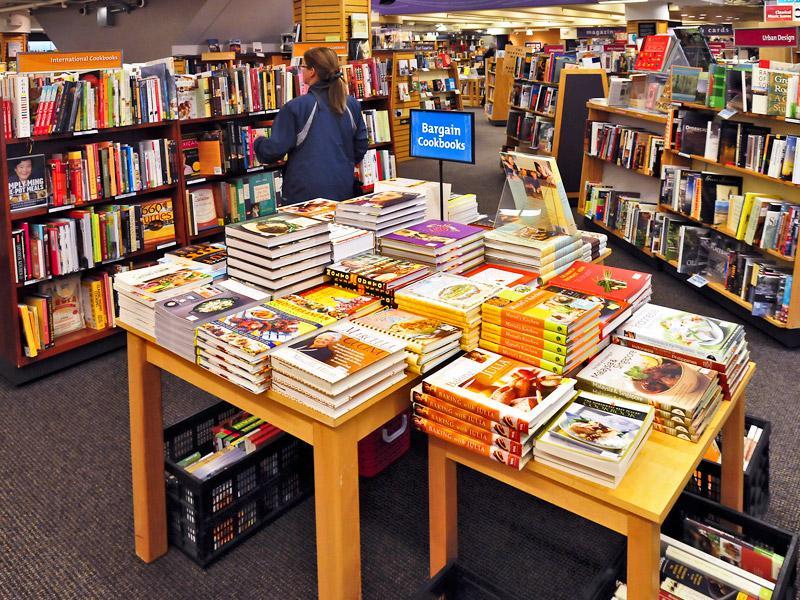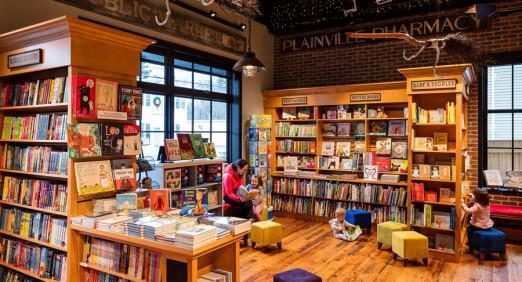The first image is the image on the left, the second image is the image on the right. Examine the images to the left and right. Is the description "One bookstore interior shows central table displays flanked by empty aisles, and the other interior shows a table display with upright and flat books." accurate? Answer yes or no. No. The first image is the image on the left, the second image is the image on the right. For the images shown, is this caption "In one image, wooden tables in the foreground of a bookstore are stacked with books for sale, with more books visible on the floor under or near the tables." true? Answer yes or no. Yes. 